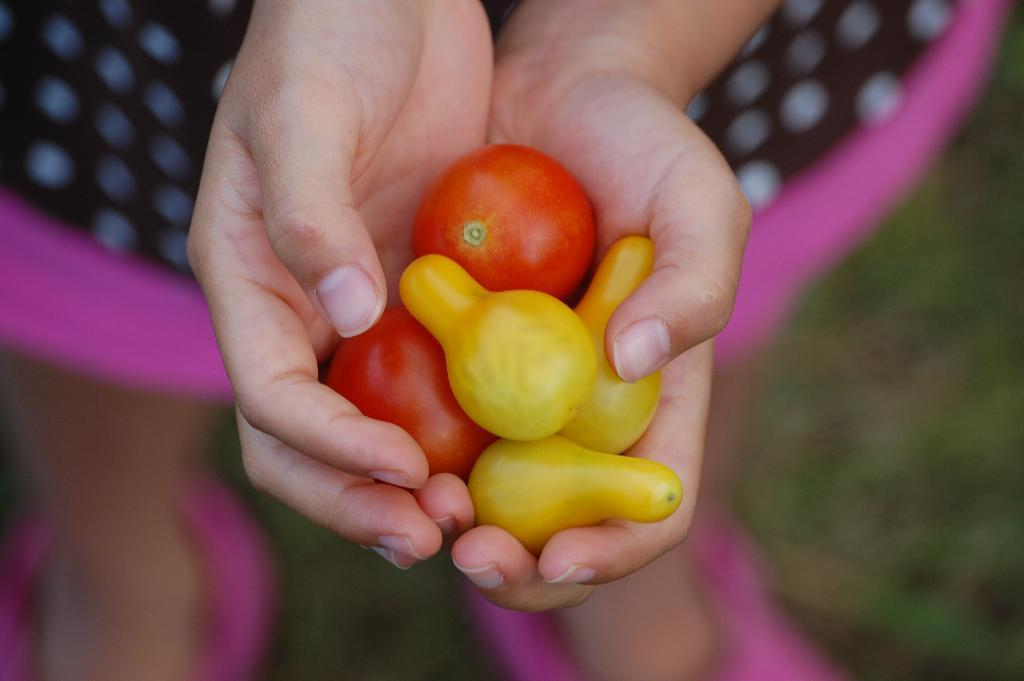What is the main subject of the image? There is a person standing in the image. What is the person holding in the image? The person is holding tomatoes and other vegetable items. Can you describe the background of the image? The background of the image is blurry. What type of cream can be seen on the actor's face in the image? There is no actor or cream present in the image; it features a person holding tomatoes and other vegetable items with a blurry background. 